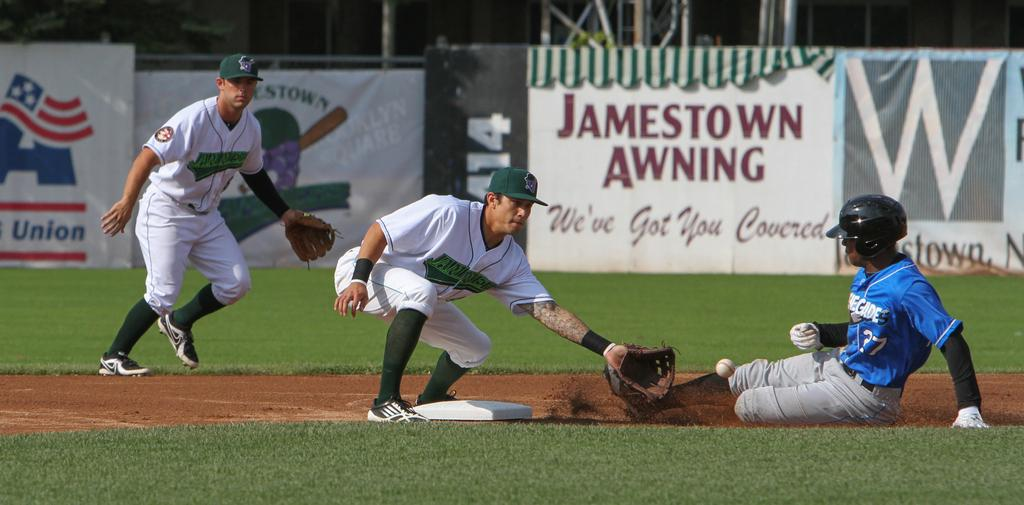<image>
Render a clear and concise summary of the photo. An ad for "Jamestown Awning" is in a baseball field. 